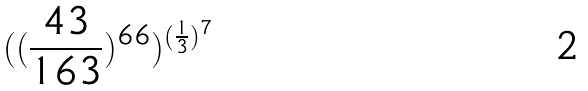Convert formula to latex. <formula><loc_0><loc_0><loc_500><loc_500>( ( \frac { 4 3 } { 1 6 3 } ) ^ { 6 6 } ) ^ { ( \frac { 1 } { 3 } ) ^ { 7 } }</formula> 